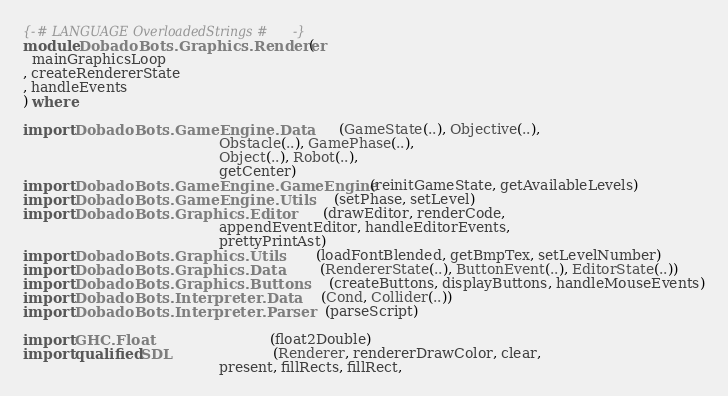Convert code to text. <code><loc_0><loc_0><loc_500><loc_500><_Haskell_>{-# LANGUAGE OverloadedStrings #-}
module DobadoBots.Graphics.Renderer (
  mainGraphicsLoop
, createRendererState 
, handleEvents
) where

import DobadoBots.GameEngine.Data          (GameState(..), Objective(..), 
                                            Obstacle(..), GamePhase(..),
                                            Object(..), Robot(..), 
                                            getCenter)
import DobadoBots.GameEngine.GameEngine    (reinitGameState, getAvailableLevels)
import DobadoBots.GameEngine.Utils         (setPhase, setLevel)
import DobadoBots.Graphics.Editor          (drawEditor, renderCode,
                                            appendEventEditor, handleEditorEvents,
                                            prettyPrintAst)
import DobadoBots.Graphics.Utils           (loadFontBlended, getBmpTex, setLevelNumber)
import DobadoBots.Graphics.Data            (RendererState(..), ButtonEvent(..), EditorState(..))
import DobadoBots.Graphics.Buttons         (createButtons, displayButtons, handleMouseEvents)
import DobadoBots.Interpreter.Data         (Cond, Collider(..))
import DobadoBots.Interpreter.Parser       (parseScript)

import GHC.Float                           (float2Double)
import qualified SDL                       (Renderer, rendererDrawColor, clear,
                                            present, fillRects, fillRect, </code> 